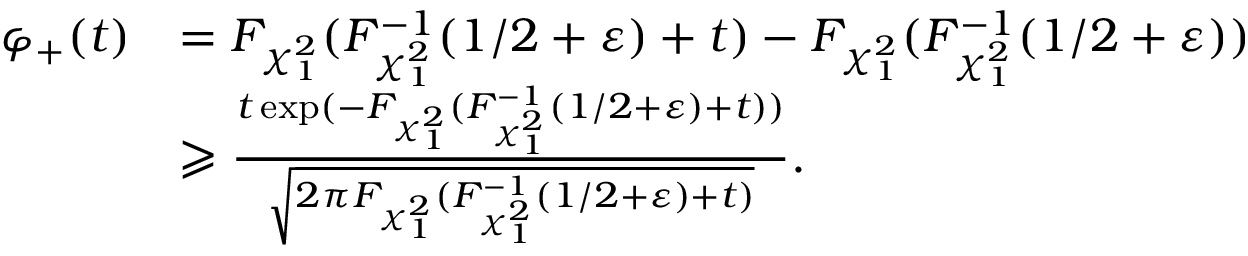Convert formula to latex. <formula><loc_0><loc_0><loc_500><loc_500>\begin{array} { r l } { \varphi _ { + } ( t ) } & { = F _ { \chi _ { 1 } ^ { 2 } } ( F _ { \chi _ { 1 } ^ { 2 } } ^ { - 1 } ( 1 / 2 + \varepsilon ) + t ) - F _ { \chi _ { 1 } ^ { 2 } } ( F _ { \chi _ { 1 } ^ { 2 } } ^ { - 1 } ( 1 / 2 + \varepsilon ) ) } \\ & { \geqslant \frac { t \exp ( - F _ { \chi _ { 1 } ^ { 2 } } ( F _ { \chi _ { 1 } ^ { 2 } } ^ { - 1 } ( 1 / 2 + \varepsilon ) + t ) ) } { \sqrt { 2 \pi F _ { \chi _ { 1 } ^ { 2 } } ( F _ { \chi _ { 1 } ^ { 2 } } ^ { - 1 } ( 1 / 2 + \varepsilon ) + t ) } } . } \end{array}</formula> 